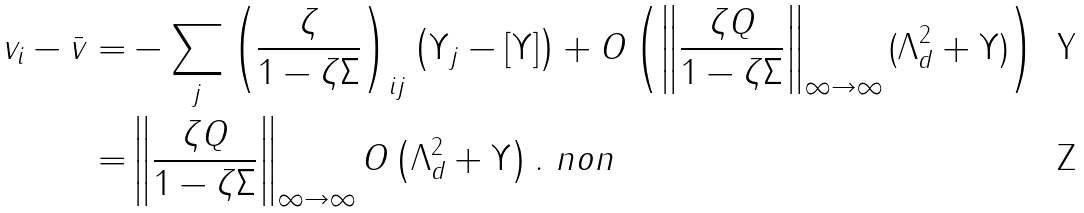<formula> <loc_0><loc_0><loc_500><loc_500>v _ { i } - \bar { v } = & - \sum _ { j } \left ( \frac { \zeta } { 1 - \zeta \Sigma } \right ) _ { i j } \left ( \Upsilon _ { j } - [ \Upsilon ] \right ) + O \left ( \left \| \frac { \zeta Q } { 1 - \zeta \Sigma } \right \| _ { \infty \to \infty } ( \Lambda _ { d } ^ { 2 } + \Upsilon ) \right ) \\ = & \left \| \frac { \zeta Q } { 1 - \zeta \Sigma } \right \| _ { \infty \to \infty } O \left ( \Lambda ^ { 2 } _ { d } + \Upsilon \right ) . \ n o n</formula> 